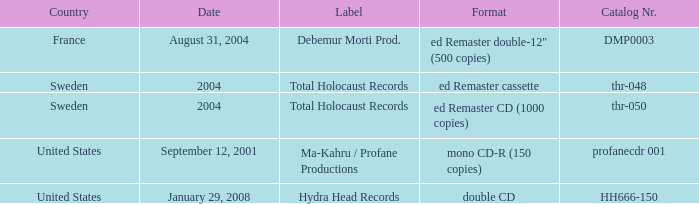Which country has the format ed Remaster double-12" (500 copies)? France. 